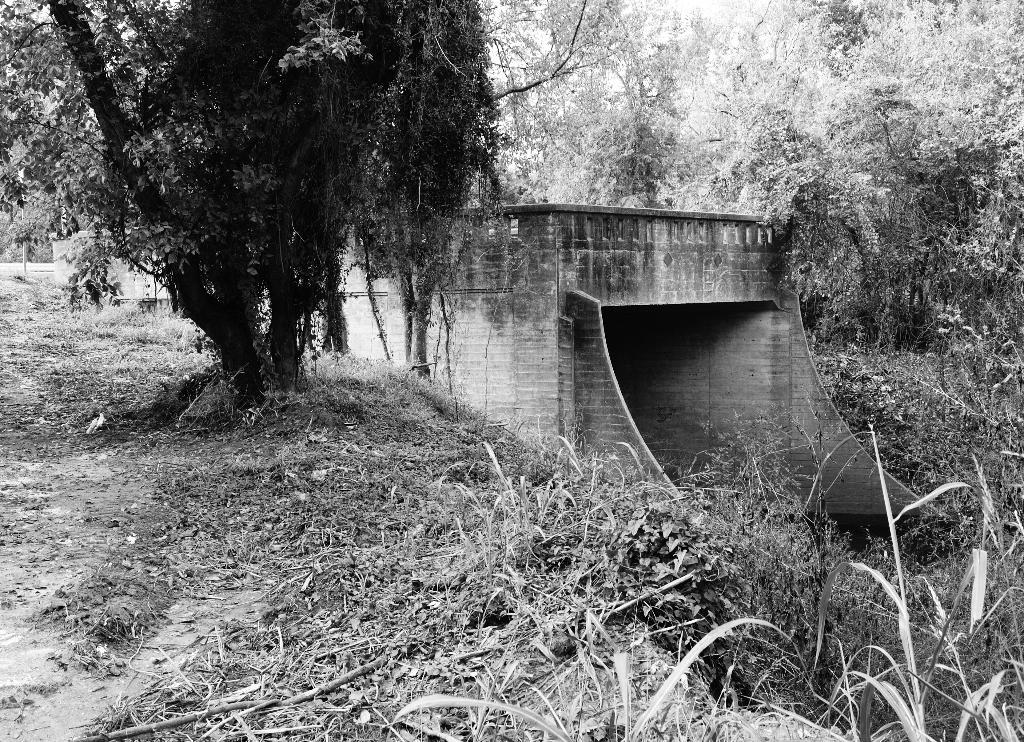What type of vegetation can be seen in the image? There are trees in the image. What else can be seen on the ground in the image? There is grass in the image. What structure is present in the image that allows people or vehicles to cross over a body of water? There is a bridge in the image. What is visible in the background of the image? The sky is visible in the image. What is the title of the plant featured in the image? There is no plant present in the image, only trees. What force is causing the bridge to move in the image? The bridge is not moving in the image; it is stationary. 